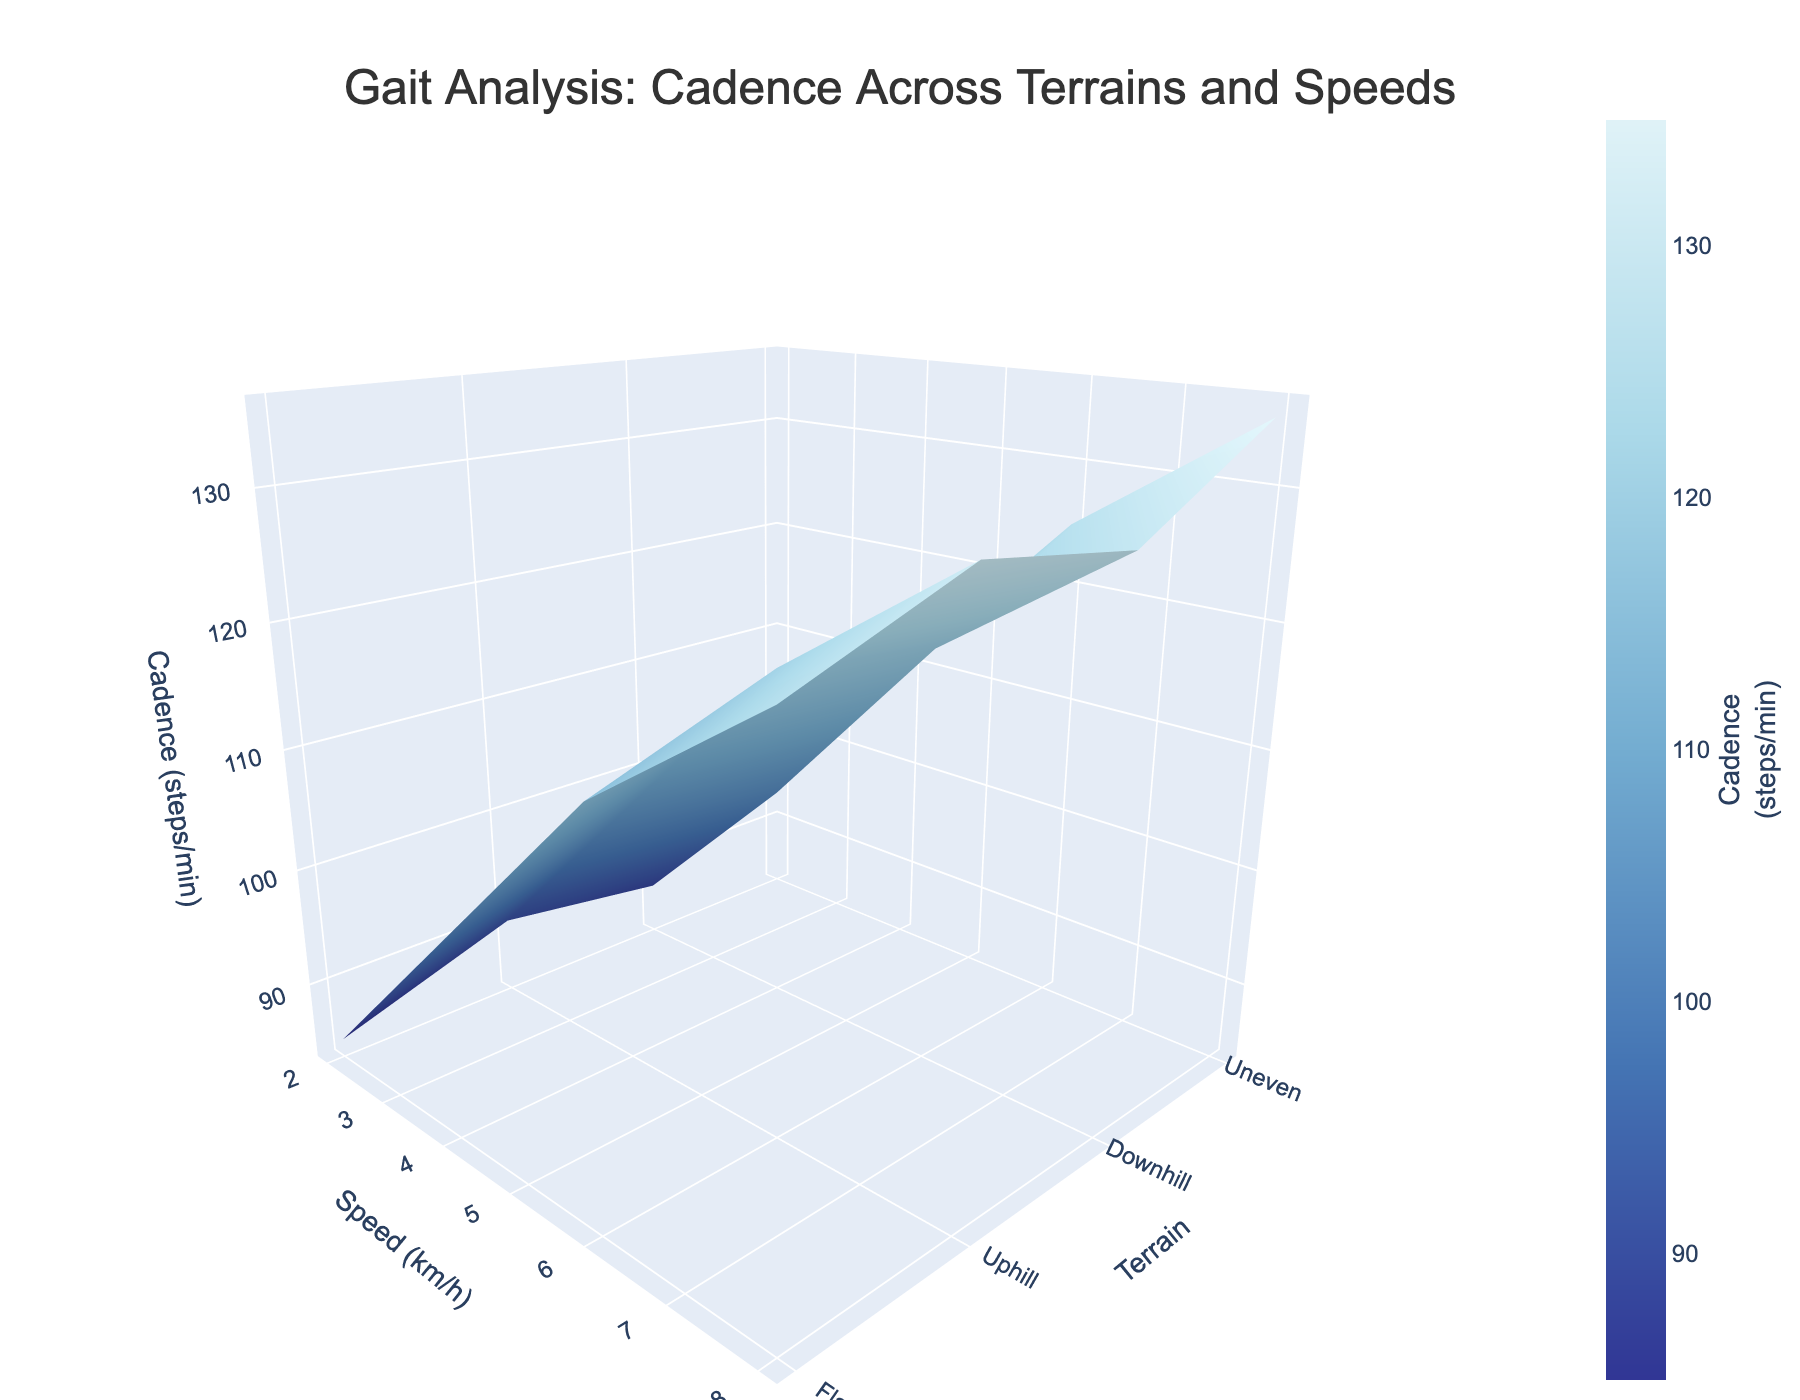What is the title of the figure? The title is located at the top of the figure and provides a summary of the information being shown. It reads "Gait Analysis: Cadence Across Terrains and Speeds"
Answer: Gait Analysis: Cadence Across Terrains and Speeds What does the colorbar represent? The colorbar, located on the right side of the plot, indicates that it represents "Cadence (steps/min)" with colors ranging from dark blue to light colors.
Answer: Cadence (steps/min) Which terrain has the highest cadence at 2 km/h? To identify the terrain with the highest cadence at 2 km/h, observe the plot at Speed (x-axis) = 2 km/h and look for the highest point along the Terrain (y-axis). The highest point in terms of Z-axis (Cadence) is for the "Uphill" terrain.
Answer: Uphill At 4 km/h, how much higher is the cadence on uphill terrain compared to flat terrain? First, find the cadences for both terrains at 4 km/h. For Uphill, the cadence is about 110 steps/min. For Flat, the cadence is about 105 steps/min. The difference between them is 110 - 105 = 5 steps/min.
Answer: 5 steps/min What is the trend of cadence as walking speed increases on uneven terrain? To identify the trend on uneven terrain, observe the surface plot for the row corresponding to "Uneven". As the speed (x-axis) increases from 2 km/h to 8 km/h, the cadence (z-axis) tends to increase from 88 to 128 steps/min.
Answer: Cadence increases Is there any terrain where cadence decreases with increasing speed? By examining the 3D plot, notice that for Downhill terrain, cadence increases with speed up to 6 km/h and maintains the same level when speed transitions from 6 to 8 km/h. Since there is no decrease in cadence with increasing speed in any terrain, the answer is no.
Answer: No At which speed does the cadence approximately reach 130 steps/min on flat terrain? Locate the section of the plot where Terrain is "Flat" and find the speed on the x-axis where the corresponding cadence on the z-axis is around 130 steps/min. It occurs approximately at 8 km/h.
Answer: 8 km/h Compare the cadence values at 6 km/h across all terrains. Which terrain shows the lowest cadence? To compare the cadence at 6 km/h, we need to check the z-axis values for different terrains vertically aligned with 6 km/h on the x-axis. The values are approximately 120 (Flat), 125 (Uphill), 115 (Downhill), and 118 (Uneven). The lowest cadence is for "Downhill".
Answer: Downhill What is the total difference in cadence between the lowest and highest recorded cadences on uneven terrain? Observe the cadences for Uneven terrain, with values 88, 102, 118, and 128 steps/min. The difference between the highest (128) and the lowest (88) is 128 - 88 = 40 steps/min.
Answer: 40 steps/min 